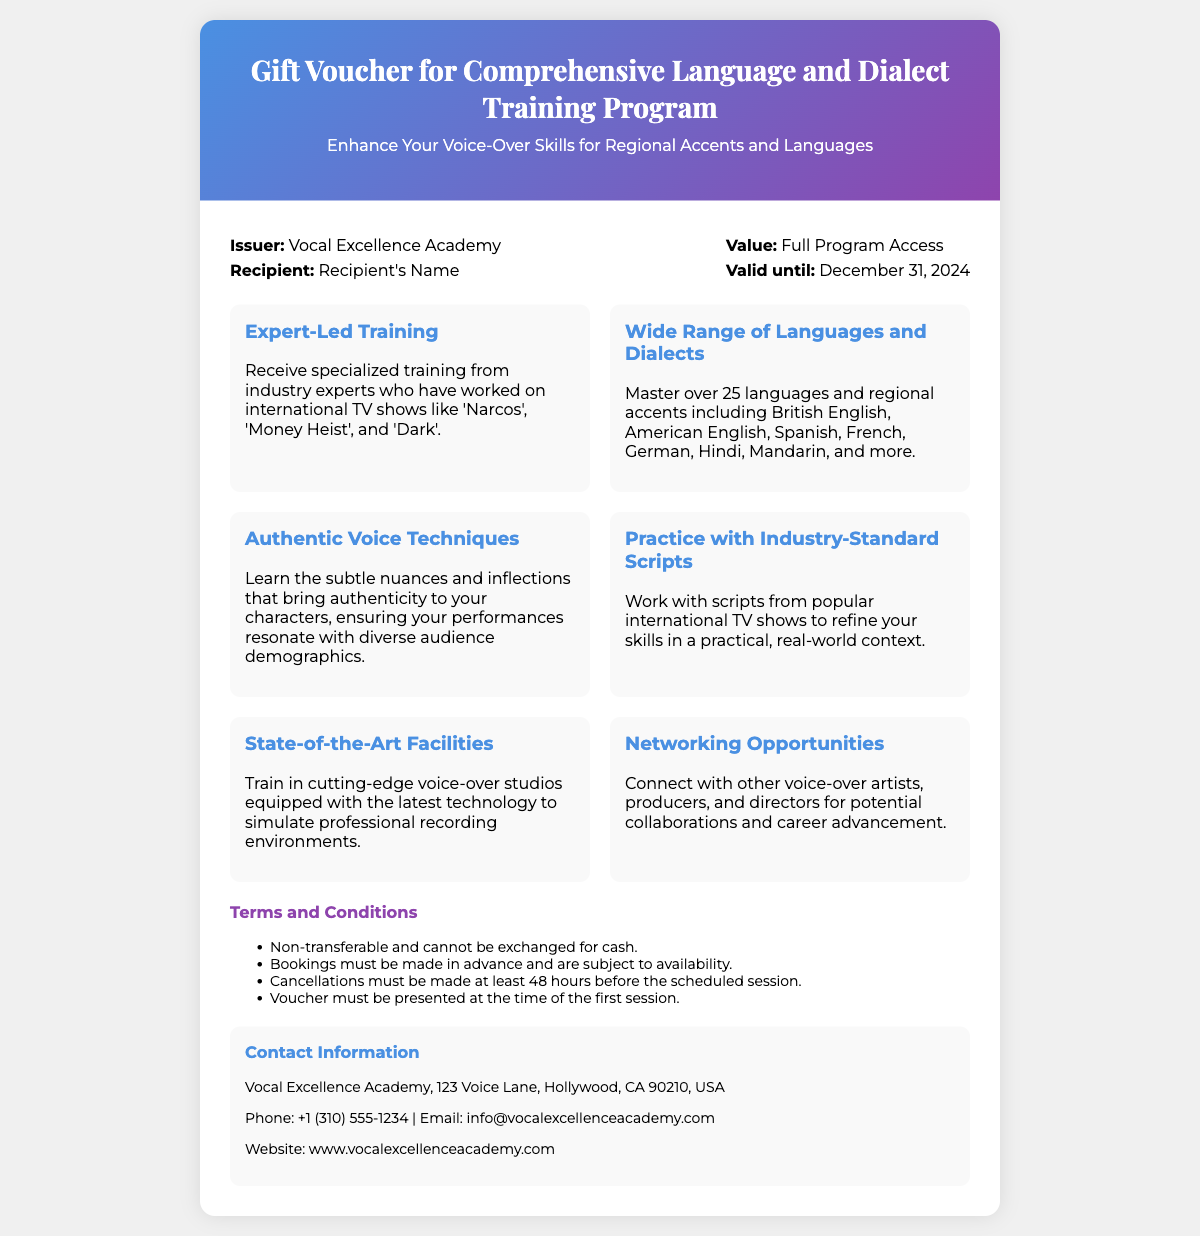What is the issuer of the voucher? The issuer of the voucher is stated in the document, specifying the organization providing the training program.
Answer: Vocal Excellence Academy What is the validity date of the voucher? The validity date indicates the last day this voucher can be used, found in the document.
Answer: December 31, 2024 How many languages and dialects can be mastered through this program? The document mentions an exact figure corresponding to the variety of languages and dialects included in the training.
Answer: Over 25 What essential skill is emphasized in the "Authentic Voice Techniques" feature? This feature highlights a crucial aspect of voice-over training that is necessary for performances.
Answer: Nuances and inflections What should be done if a cancellation is needed? This refers to the required action and time frame mentioned in the document regarding session cancellations.
Answer: Made at least 48 hours before What is included in the "Networking Opportunities" feature? The document refers to a benefit related to connections within the industry mentioned in the networking feature.
Answer: Potential collaborations What type of training is the program primarily focused on? The program’s focus is clearly identified in the title of the voucher, specifying its intent.
Answer: Voice-Over Skills What facilities are available for training? The document describes the kind of environment the training takes place in, reflecting on its quality.
Answer: State-of-the-Art Facilities 